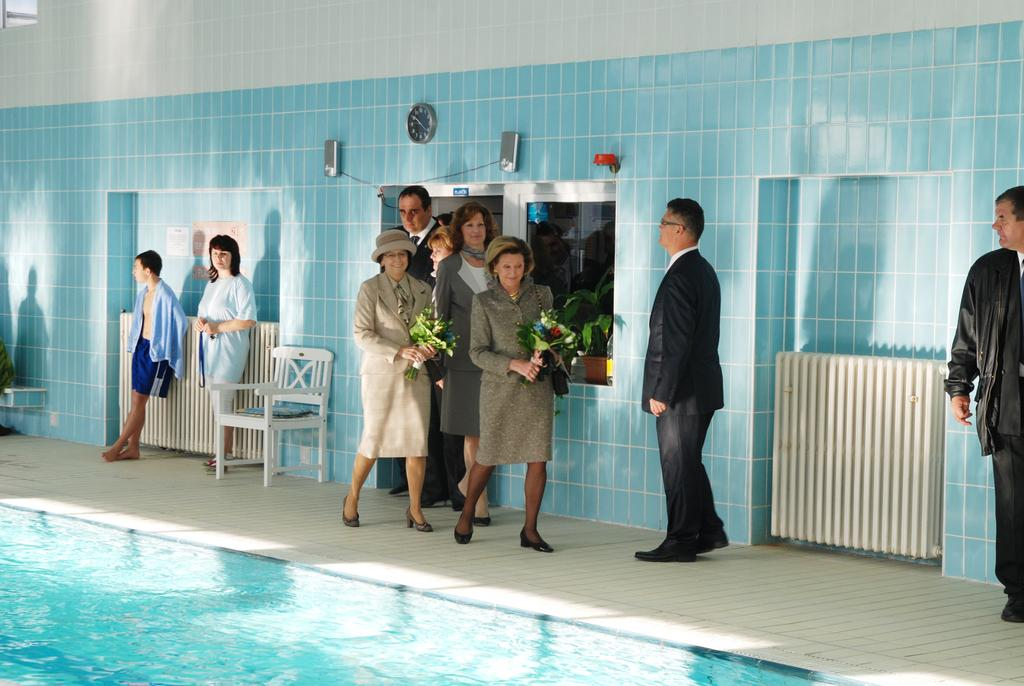What is the main feature in the image? There is a swimming pool in the image. What else can be seen in the image besides the swimming pool? There is a wall, a window, a chair, and people in the image. Can you describe the people in the image? Two people are holding bouquets. What type of rhythm can be heard coming from the swimming pool in the image? There is no sound or rhythm associated with the swimming pool in the image. 